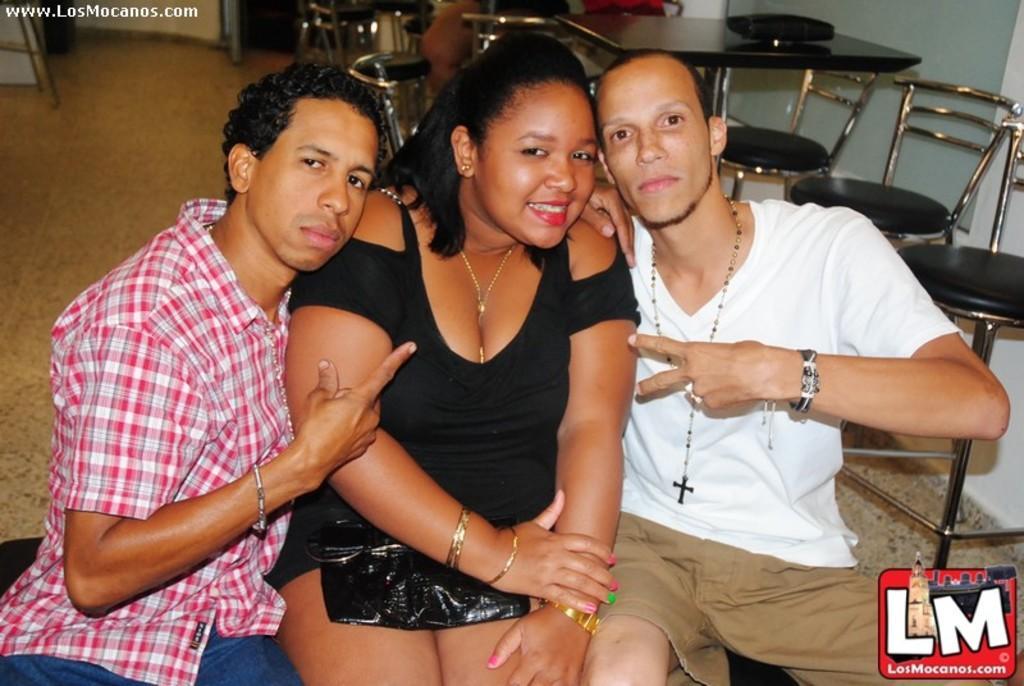Could you give a brief overview of what you see in this image? In this picture I can see couple of men and women seated and I can see few chairs and a table and I can see text at the top left corner and logo at the bottom right corner of the picture. 